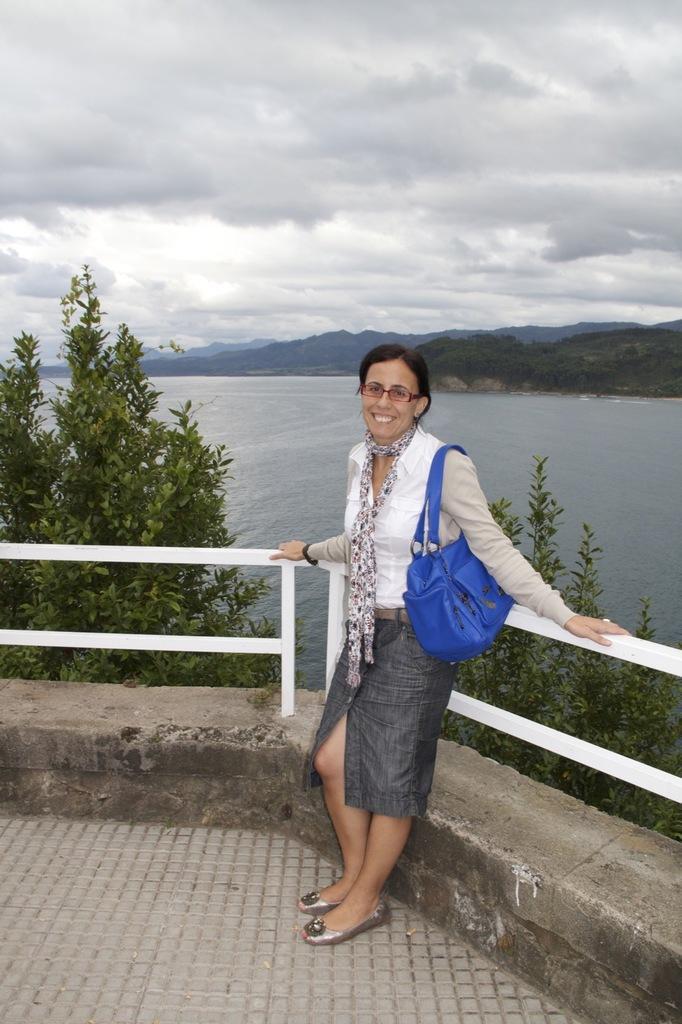Describe this image in one or two sentences. In this image I can see a person,smiling and holding the bag. At the back there is a tree,water,mountain and the sky. 